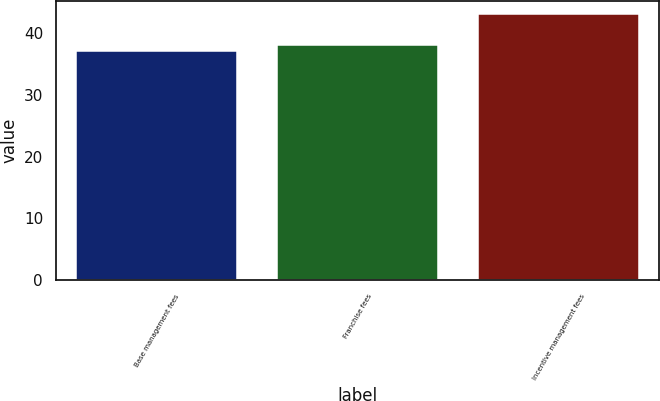<chart> <loc_0><loc_0><loc_500><loc_500><bar_chart><fcel>Base management fees<fcel>Franchise fees<fcel>Incentive management fees<nl><fcel>37<fcel>38<fcel>43<nl></chart> 